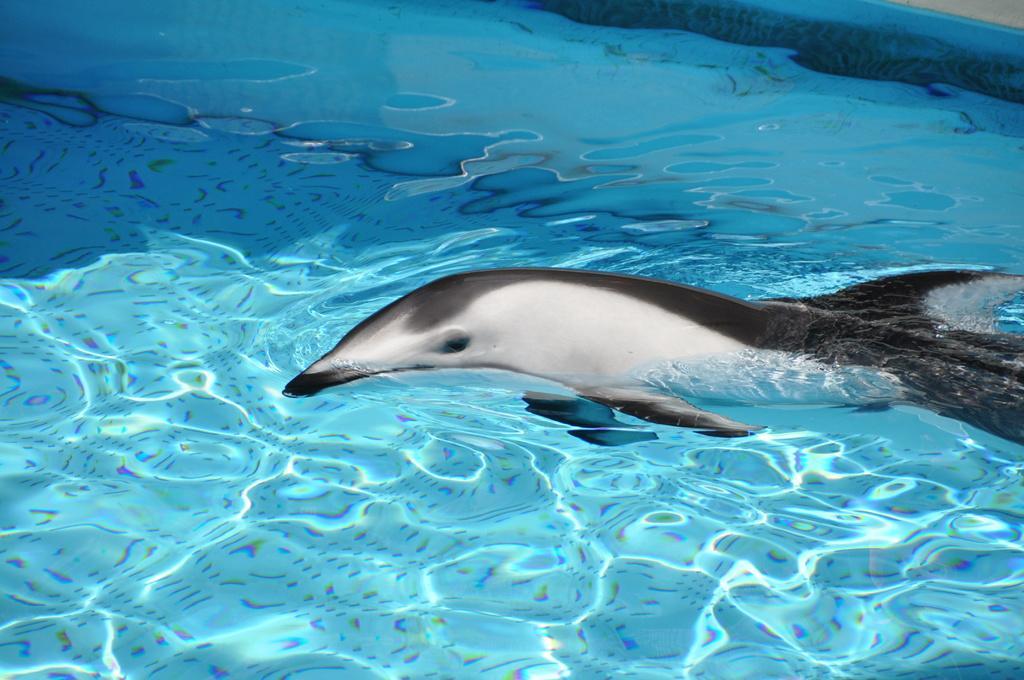How would you summarize this image in a sentence or two? In this picture there is a dolphin in the water. 